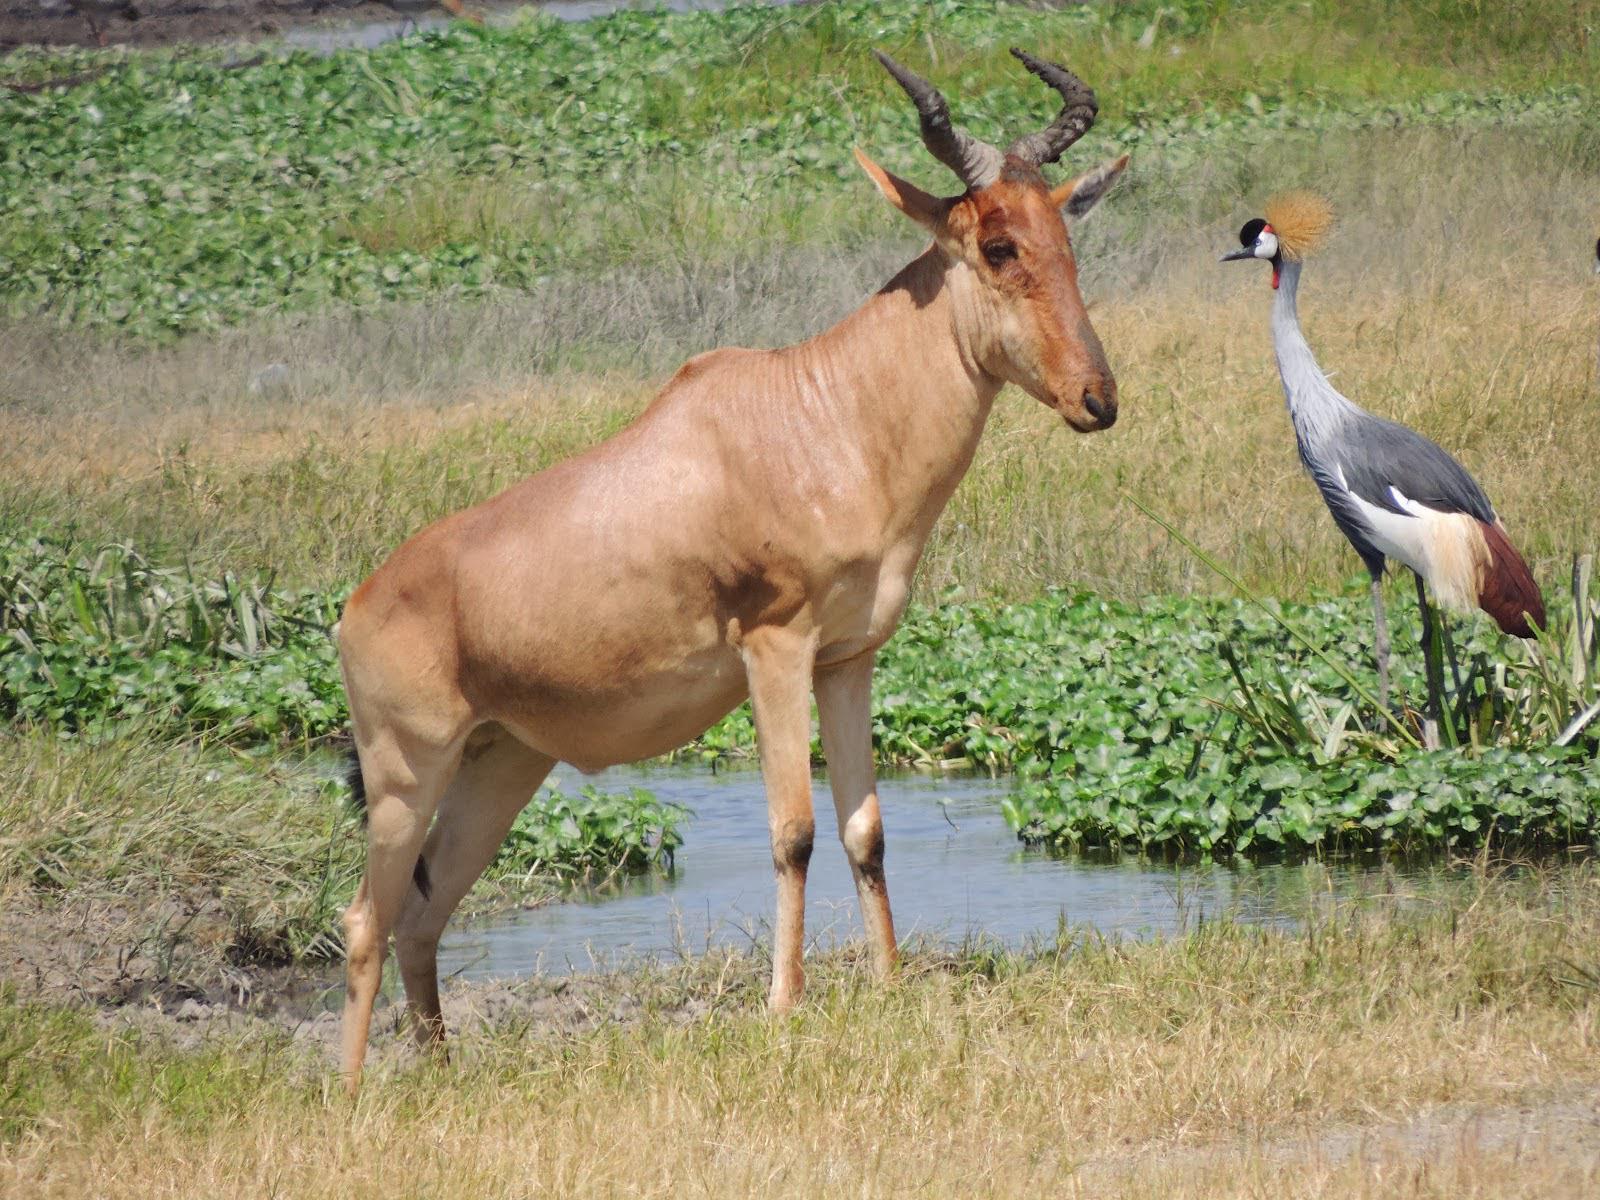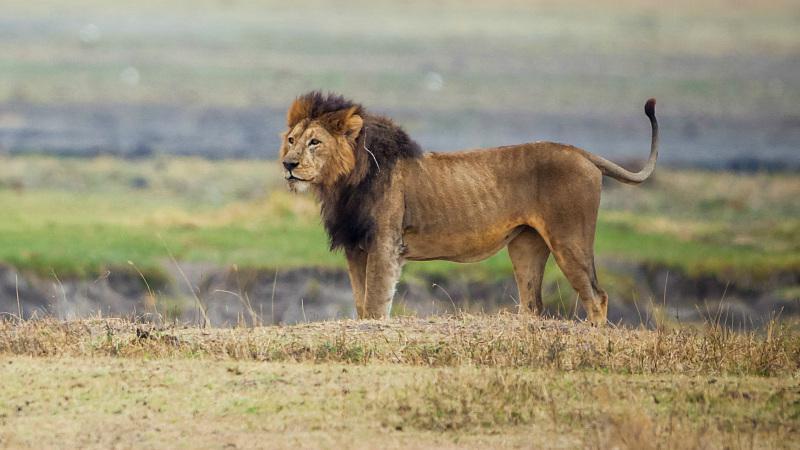The first image is the image on the left, the second image is the image on the right. Analyze the images presented: Is the assertion "There are two antelope together in the right image." valid? Answer yes or no. No. 